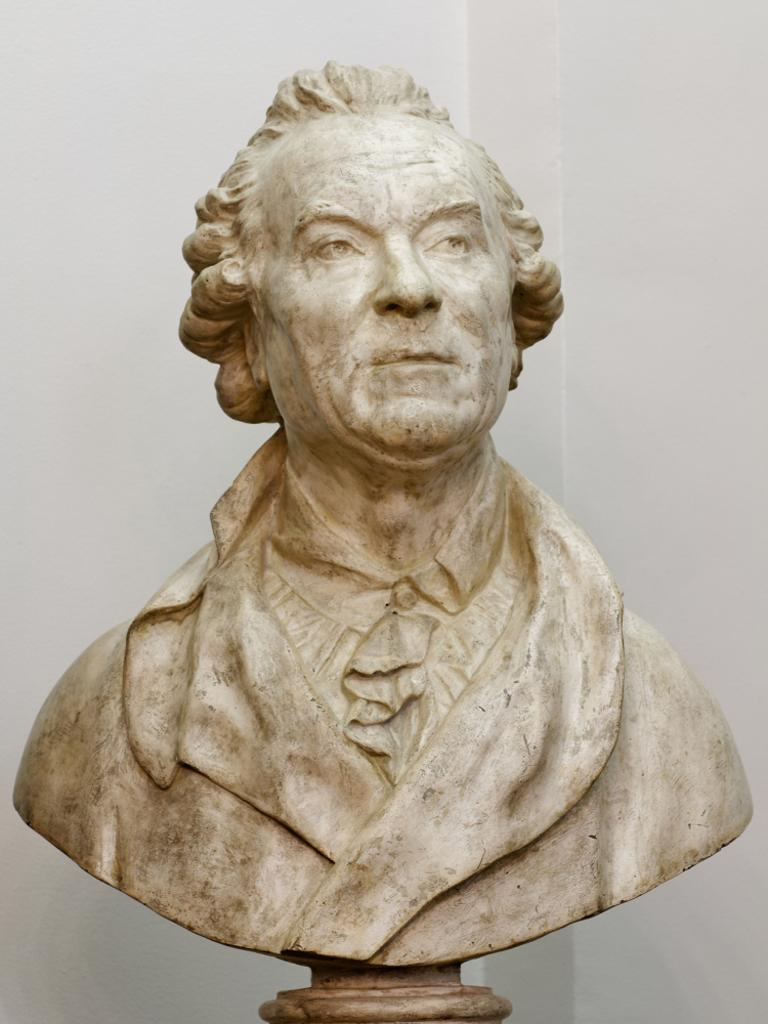What is the main subject of the image? There is a depiction of a man in the image. What can be seen in the background of the image? There is a plain wall in the background of the image. How many legs of chalk can be seen in the image? There is no chalk or legs of chalk present in the image. 